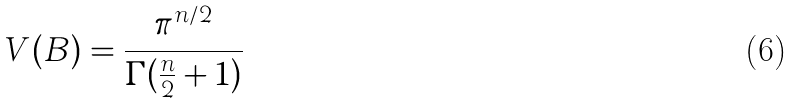<formula> <loc_0><loc_0><loc_500><loc_500>V ( B ) = \frac { { \pi } ^ { n / 2 } } { \Gamma ( \frac { n } { 2 } + 1 ) }</formula> 